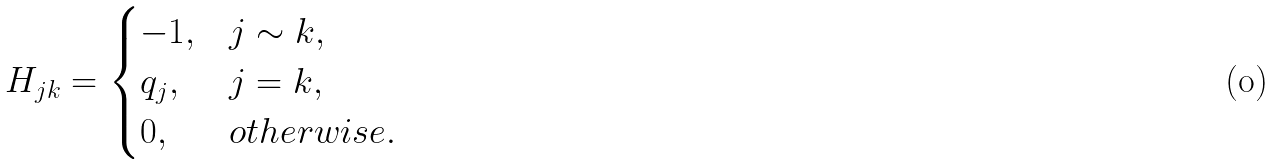Convert formula to latex. <formula><loc_0><loc_0><loc_500><loc_500>H _ { j k } = \begin{cases} - 1 , & j \sim k , \\ q _ { j } , & j = k , \\ 0 , & o t h e r w i s e . \end{cases}</formula> 